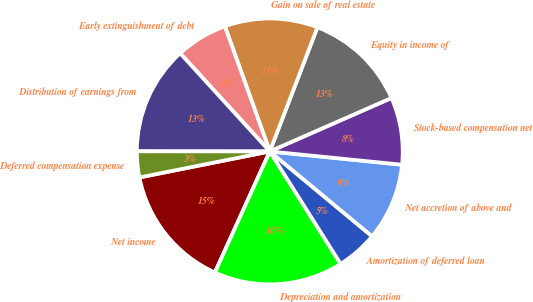Convert chart to OTSL. <chart><loc_0><loc_0><loc_500><loc_500><pie_chart><fcel>Net income<fcel>Depreciation and amortization<fcel>Amortization of deferred loan<fcel>Net accretion of above and<fcel>Stock-based compensation net<fcel>Equity in income of<fcel>Gain on sale of real estate<fcel>Early extinguishment of debt<fcel>Distribution of earnings from<fcel>Deferred compensation expense<nl><fcel>15.09%<fcel>15.72%<fcel>5.03%<fcel>9.43%<fcel>8.18%<fcel>12.58%<fcel>11.32%<fcel>6.29%<fcel>13.21%<fcel>3.15%<nl></chart> 